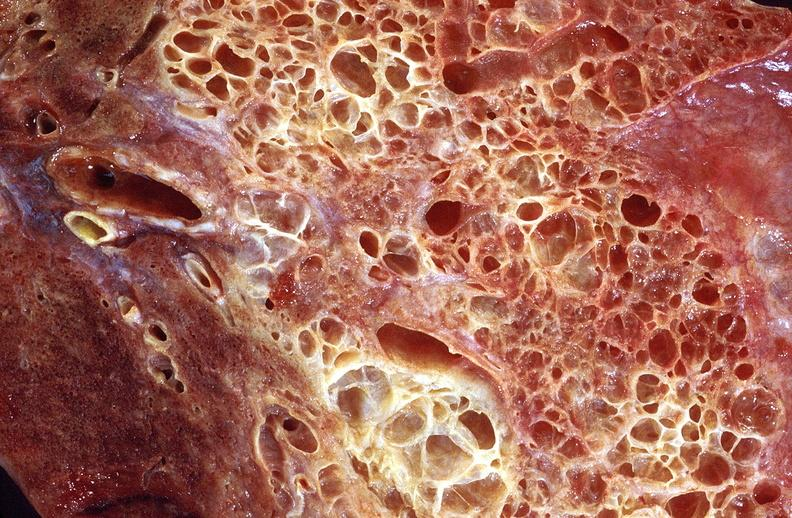does this image show lung fibrosis, scleroderma?
Answer the question using a single word or phrase. Yes 